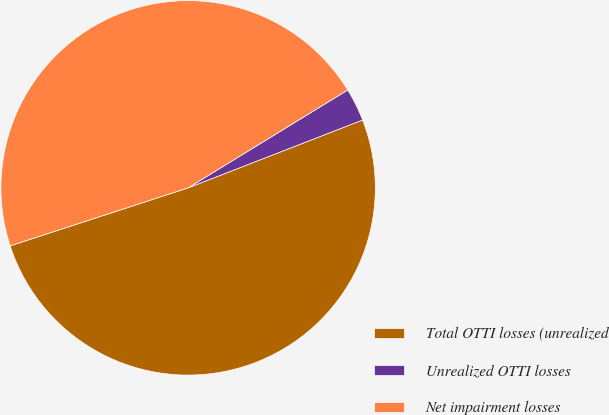Convert chart to OTSL. <chart><loc_0><loc_0><loc_500><loc_500><pie_chart><fcel>Total OTTI losses (unrealized<fcel>Unrealized OTTI losses<fcel>Net impairment losses<nl><fcel>50.89%<fcel>2.85%<fcel>46.26%<nl></chart> 